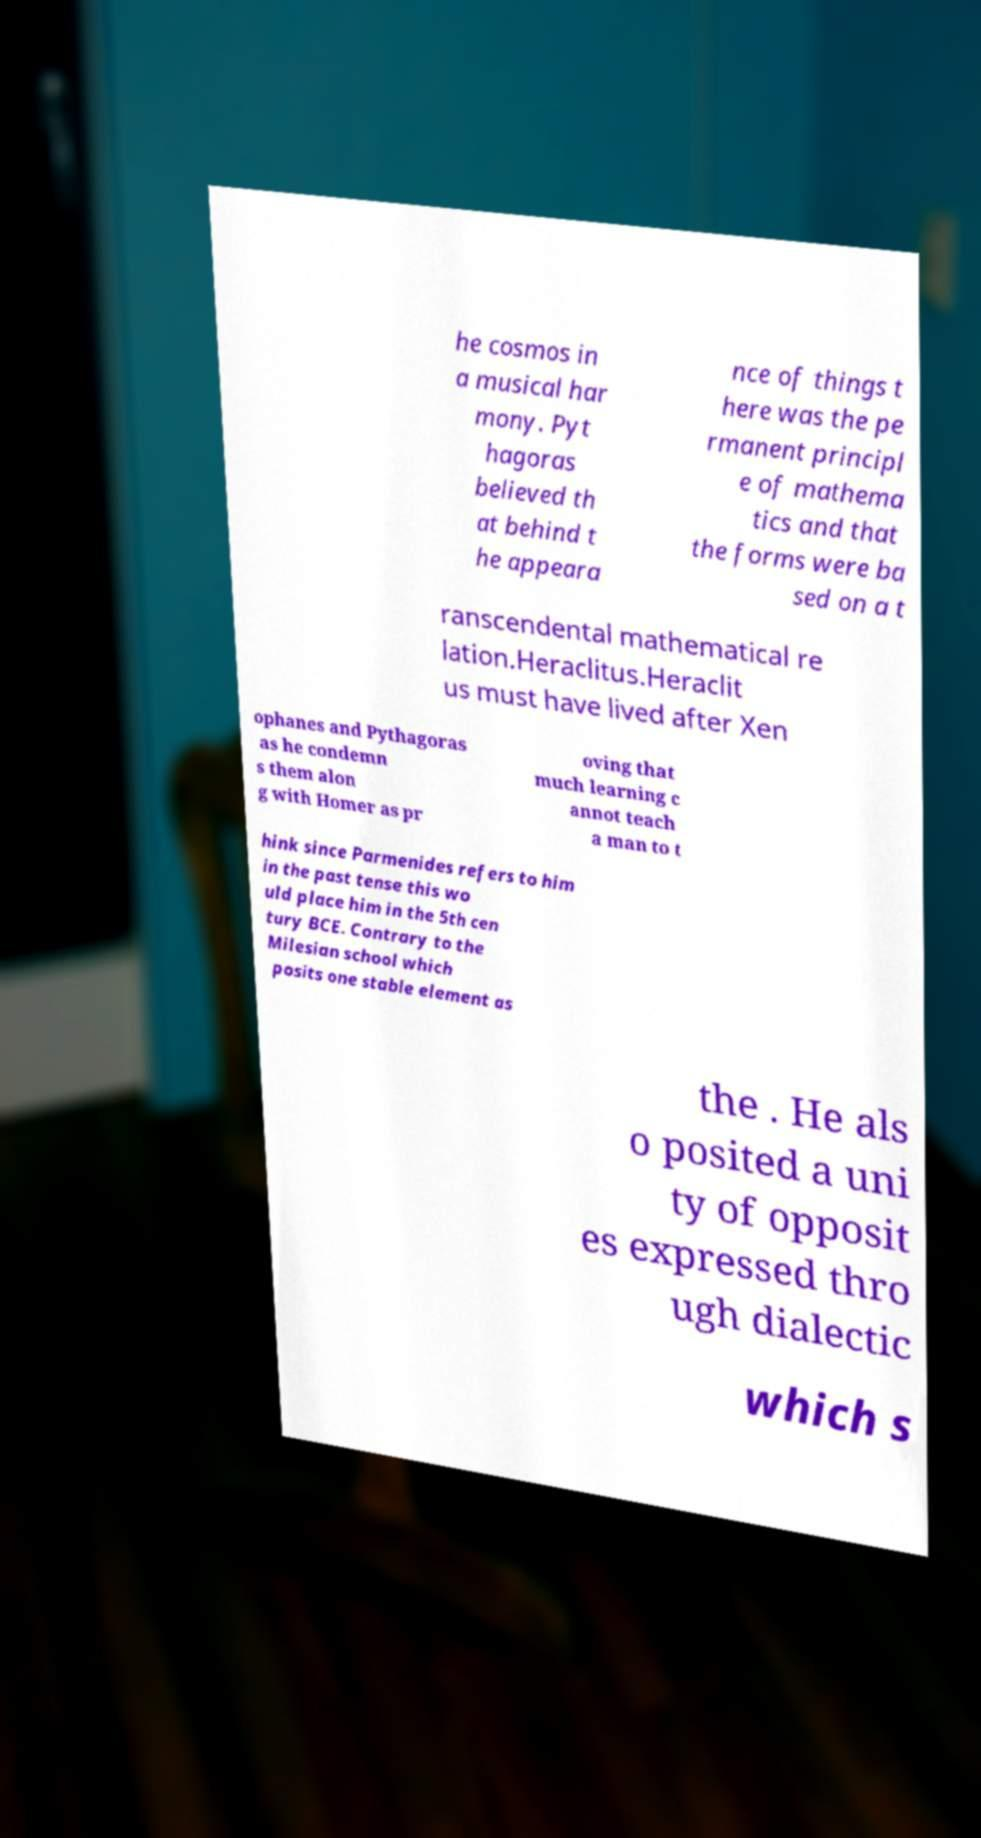Can you read and provide the text displayed in the image?This photo seems to have some interesting text. Can you extract and type it out for me? he cosmos in a musical har mony. Pyt hagoras believed th at behind t he appeara nce of things t here was the pe rmanent principl e of mathema tics and that the forms were ba sed on a t ranscendental mathematical re lation.Heraclitus.Heraclit us must have lived after Xen ophanes and Pythagoras as he condemn s them alon g with Homer as pr oving that much learning c annot teach a man to t hink since Parmenides refers to him in the past tense this wo uld place him in the 5th cen tury BCE. Contrary to the Milesian school which posits one stable element as the . He als o posited a uni ty of opposit es expressed thro ugh dialectic which s 